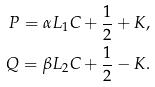<formula> <loc_0><loc_0><loc_500><loc_500>P = \alpha L _ { 1 } C + \frac { 1 } { 2 } + K , \\ Q = \beta L _ { 2 } C + \frac { 1 } { 2 } - K .</formula> 